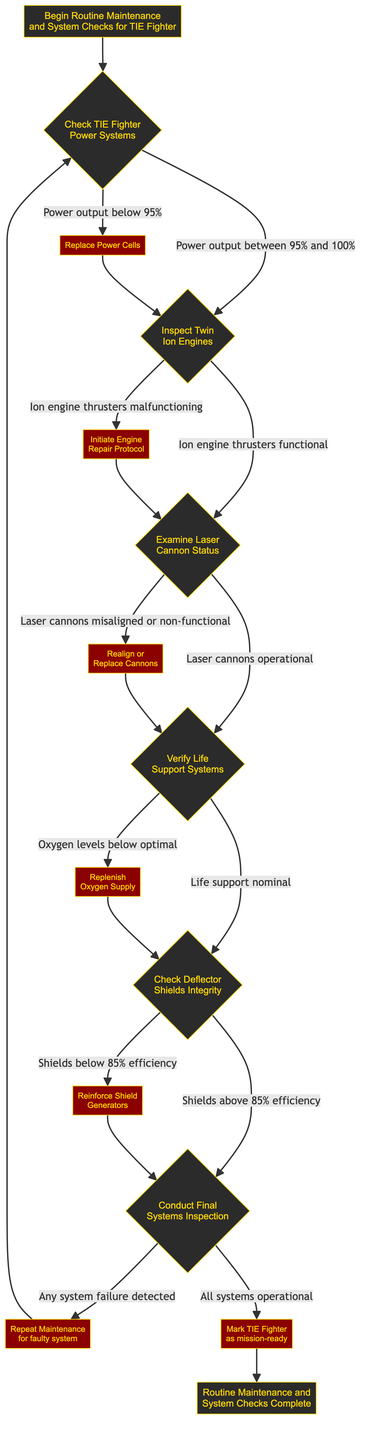What is the first step in the routine maintenance? The first step, as indicated in the diagram, begins with "Begin Routine Maintenance and System Checks for TIE Fighter."
Answer: Begin Routine Maintenance and System Checks for TIE Fighter What action is taken if power output is below 95%? If the power output is below 95%, the action indicated in the diagram is to "Replace Power Cells."
Answer: Replace Power Cells How many checks are there before the final inspection? The diagram outlines five checks (Power Systems, Twin Ion Engines, Laser Cannon Status, Life Support Systems, and Deflector Shields) before conducting the final inspection.
Answer: Five checks What happens if laser cannons are misaligned? If the laser cannons are misaligned or non-functional, the indicated action in the diagram is to "Realign or Replace Cannons."
Answer: Realign or Replace Cannons What is the condition for proceeding to the final systems inspection? The condition to proceed to the final systems inspection is "Shields above 85% efficiency," as specified in the diagram.
Answer: Shields above 85% efficiency What action follows if oxygen levels are below optimal? If oxygen levels are below optimal, the next action to take, according to the diagram, is to "Replenish Oxygen Supply."
Answer: Replenish Oxygen Supply If any system failure is detected, what should be done? The diagram states that if any system failure is detected during the final inspection, the appropriate action is to "Repeat Maintenance for faulty system."
Answer: Repeat Maintenance for faulty system What indicates that the TIE Fighter is mission-ready? The TIE Fighter is marked as mission-ready when "All systems operational" is confirmed in the final systems inspection.
Answer: Mark TIE Fighter as mission-ready 